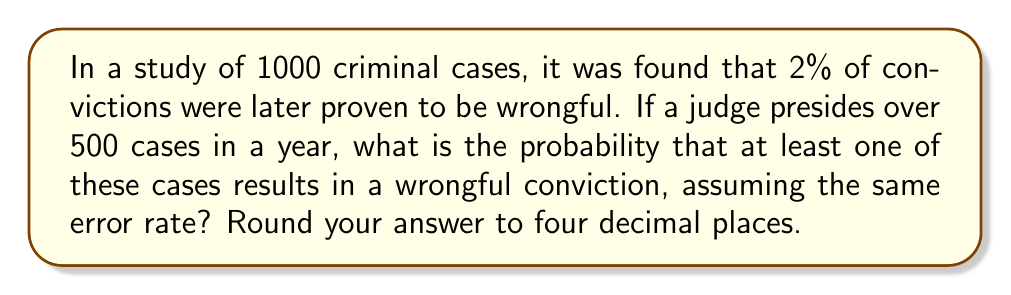Help me with this question. Let's approach this step-by-step:

1) First, we need to calculate the probability of a single case being a wrongful conviction. From the study, we know this is 2% or 0.02.

2) Now, we want to find the probability of at least one wrongful conviction in 500 cases. It's often easier to calculate the probability of the complement event (no wrongful convictions) and then subtract from 1.

3) The probability of a case not being a wrongful conviction is 1 - 0.02 = 0.98.

4) For all 500 cases to not be wrongful convictions, each individual case must not be a wrongful conviction. The probability of this is:

   $$(0.98)^{500}$$

5) Therefore, the probability of at least one wrongful conviction is:

   $$1 - (0.98)^{500}$$

6) Let's calculate this:
   
   $$1 - (0.98)^{500} = 1 - 0.00004539$$
   $$= 0.99995461$$

7) Rounding to four decimal places:

   $$0.9999$$

This high probability underscores the importance of maintaining the presumption of innocence and scrutinizing evidence carefully in each case.
Answer: 0.9999 